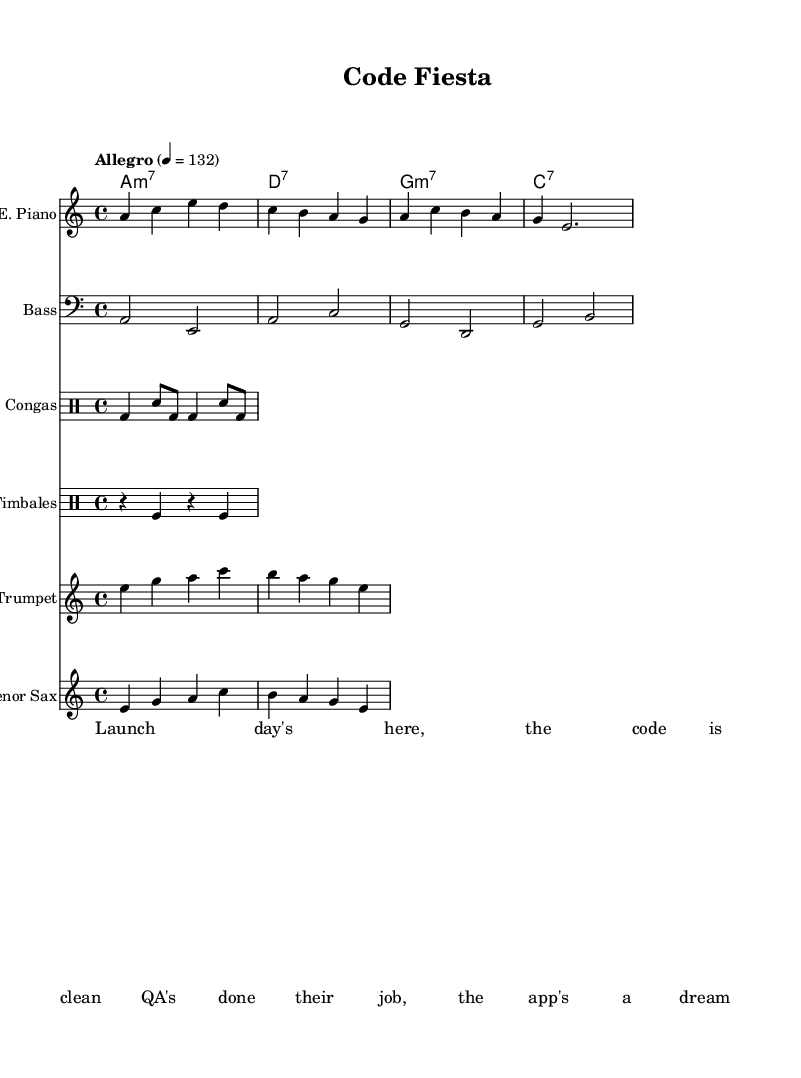What is the key signature of this music? The key signature indicates the piece is in A minor, which has no sharps or flats, suggesting a melancholic yet vibrant sound typical of Latin-funk fusion.
Answer: A minor What is the time signature of this music? The time signature shows a 4/4 format, which is common in dance music, allowing for a steady rhythm that supports the upbeat style of the composition.
Answer: 4/4 What is the tempo marking of this music? The tempo marking states "Allegro," indicating a fast and lively pace of the piece, scored at quarter note equals 132 beats per minute, fitting for a celebratory fusion.
Answer: Allegro How many instruments are featured in this score? The score includes six distinct instruments: Electric Piano, Bass, Congas, Timbales, Trumpet, and Tenor Sax, each contributing to the overall sound texture in fusion music.
Answer: Six What chord do the first two measures of the chord progression represent? The chord progression starts with A minor 7, evident in the initial chord listed, with the 'a1:m7' indicating this explicitly and setting the tonal foundation for the verse.
Answer: A minor 7 Which instrument plays rhythmically with the congas? The Timbales accompany the Congas, as both are listed under drum staffs, adding layers to the percussive foundation typical in Latin-funk fusion.
Answer: Timbales What is the primary theme or lyrical content reflected in the verse? The lyrics celebrate a successful software launch and the role of quality assurance, relating to the theme of achievement and celebration, integral to both software projects and the lively feel of fusion music.
Answer: Successful software launches 